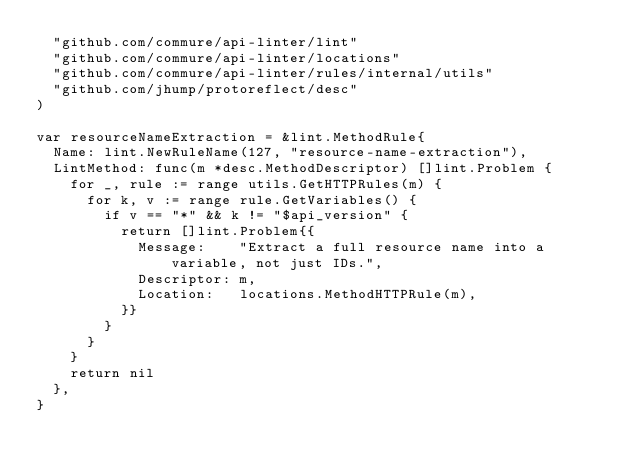<code> <loc_0><loc_0><loc_500><loc_500><_Go_>	"github.com/commure/api-linter/lint"
	"github.com/commure/api-linter/locations"
	"github.com/commure/api-linter/rules/internal/utils"
	"github.com/jhump/protoreflect/desc"
)

var resourceNameExtraction = &lint.MethodRule{
	Name: lint.NewRuleName(127, "resource-name-extraction"),
	LintMethod: func(m *desc.MethodDescriptor) []lint.Problem {
		for _, rule := range utils.GetHTTPRules(m) {
			for k, v := range rule.GetVariables() {
				if v == "*" && k != "$api_version" {
					return []lint.Problem{{
						Message:    "Extract a full resource name into a variable, not just IDs.",
						Descriptor: m,
						Location:   locations.MethodHTTPRule(m),
					}}
				}
			}
		}
		return nil
	},
}
</code> 